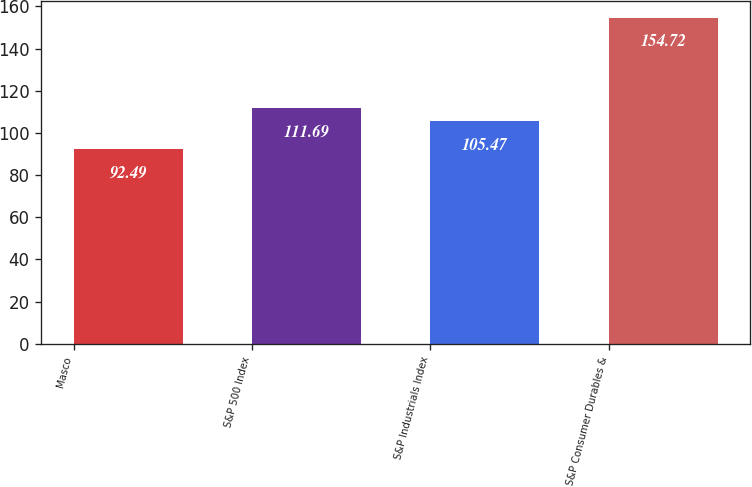Convert chart. <chart><loc_0><loc_0><loc_500><loc_500><bar_chart><fcel>Masco<fcel>S&P 500 Index<fcel>S&P Industrials Index<fcel>S&P Consumer Durables &<nl><fcel>92.49<fcel>111.69<fcel>105.47<fcel>154.72<nl></chart> 